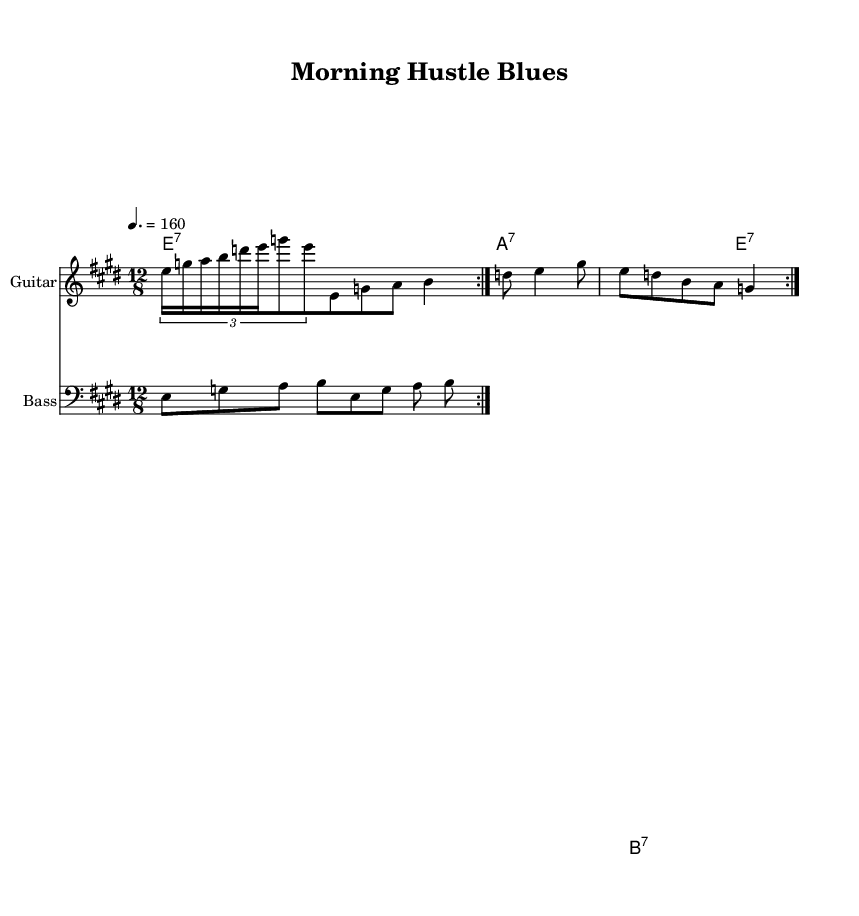What is the key signature of this music? The key signature is E major, which has four sharps (F#, C#, G#, D#). This can be confirmed by looking at the key signature at the beginning of the staff in the sheet music.
Answer: E major What is the time signature of this music? The time signature is 12/8, indicating there are four beats in a measure, each beat represented by a dotted quarter note. This is evident from the time signature notation found at the beginning of the sheet music.
Answer: 12/8 What is the tempo marking of this piece? The tempo marking is quarter note = 160, specifying the speed of the piece. This can be found below the title and gives an indication of how fast the music should be played.
Answer: 160 How many measures does the guitar part repeat? The guitar part repeats 2 times, which is indicated by the 'volta' marking, showing it will return to the start of the section and play again. This repetition is noted in the score with the repeat signs.
Answer: 2 What type of chords are used in the organ part? The organ part uses seventh chords, as indicated by the chord symbols such as E7, A7, and B7 provided beneath the staff. This is typical in blues music, providing a rich harmonic texture.
Answer: seventh chords What is the rhythmic feel of the piece? The rhythmic feel is a shuffle rhythm, common in blues, characterized by a swing in the eighth notes. This is implied by the 12/8 time signature and the arrangement of the notes within it.
Answer: shuffle Which instruments are featured in this score? The featured instruments are Guitar, Bass, and Organ, as indicated by the instrument names noted in the score above each staff. Each instrument has its designated role within the ensemble, typical for electric blues arrangements.
Answer: Guitar, Bass, Organ 